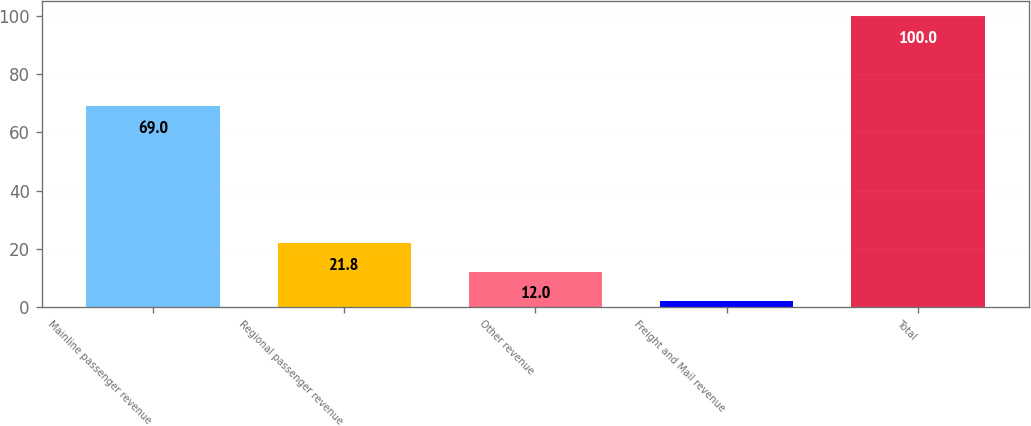<chart> <loc_0><loc_0><loc_500><loc_500><bar_chart><fcel>Mainline passenger revenue<fcel>Regional passenger revenue<fcel>Other revenue<fcel>Freight and Mail revenue<fcel>Total<nl><fcel>69<fcel>21.8<fcel>12<fcel>2<fcel>100<nl></chart> 